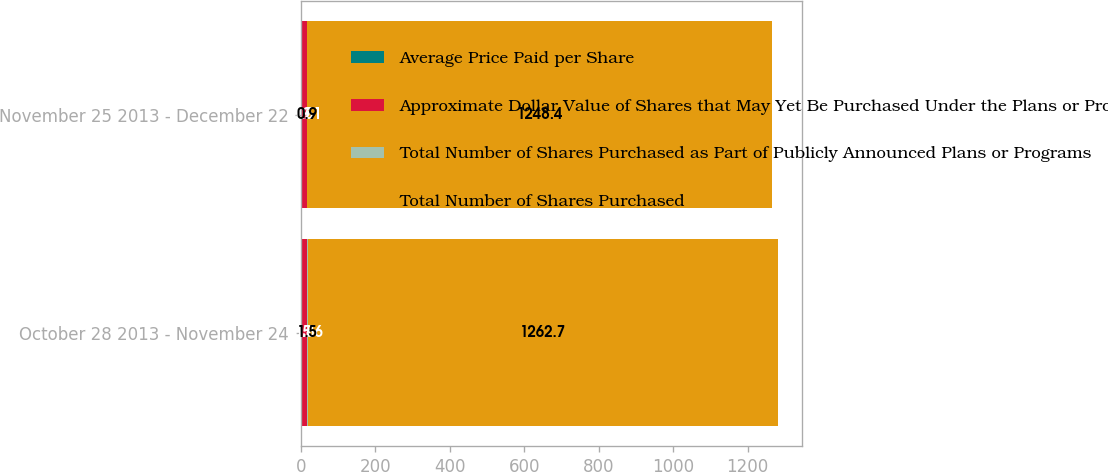Convert chart. <chart><loc_0><loc_0><loc_500><loc_500><stacked_bar_chart><ecel><fcel>October 28 2013 - November 24<fcel>November 25 2013 - December 22<nl><fcel>Average Price Paid per Share<fcel>1.5<fcel>0.9<nl><fcel>Approximate Dollar Value of Shares that May Yet Be Purchased Under the Plans or Programs<fcel>15.86<fcel>15.51<nl><fcel>Total Number of Shares Purchased as Part of Publicly Announced Plans or Programs<fcel>1.5<fcel>0.9<nl><fcel>Total Number of Shares Purchased<fcel>1262.7<fcel>1248.4<nl></chart> 